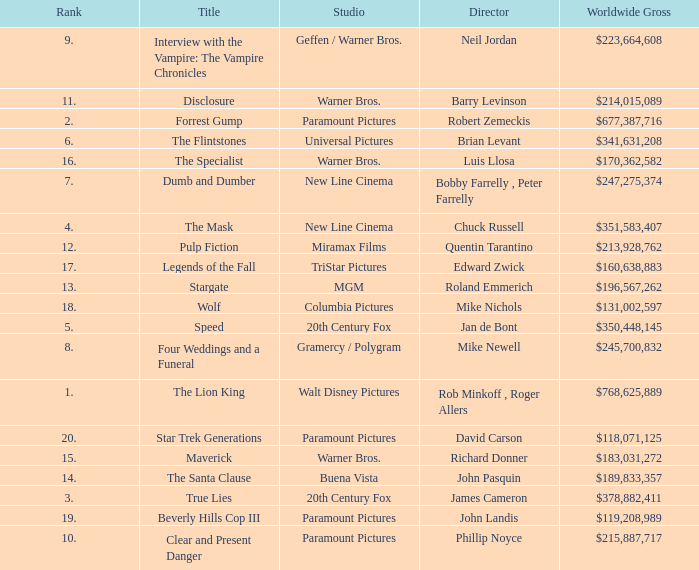What is the Worldwide Gross of the Film with a Rank of 3? $378,882,411. 